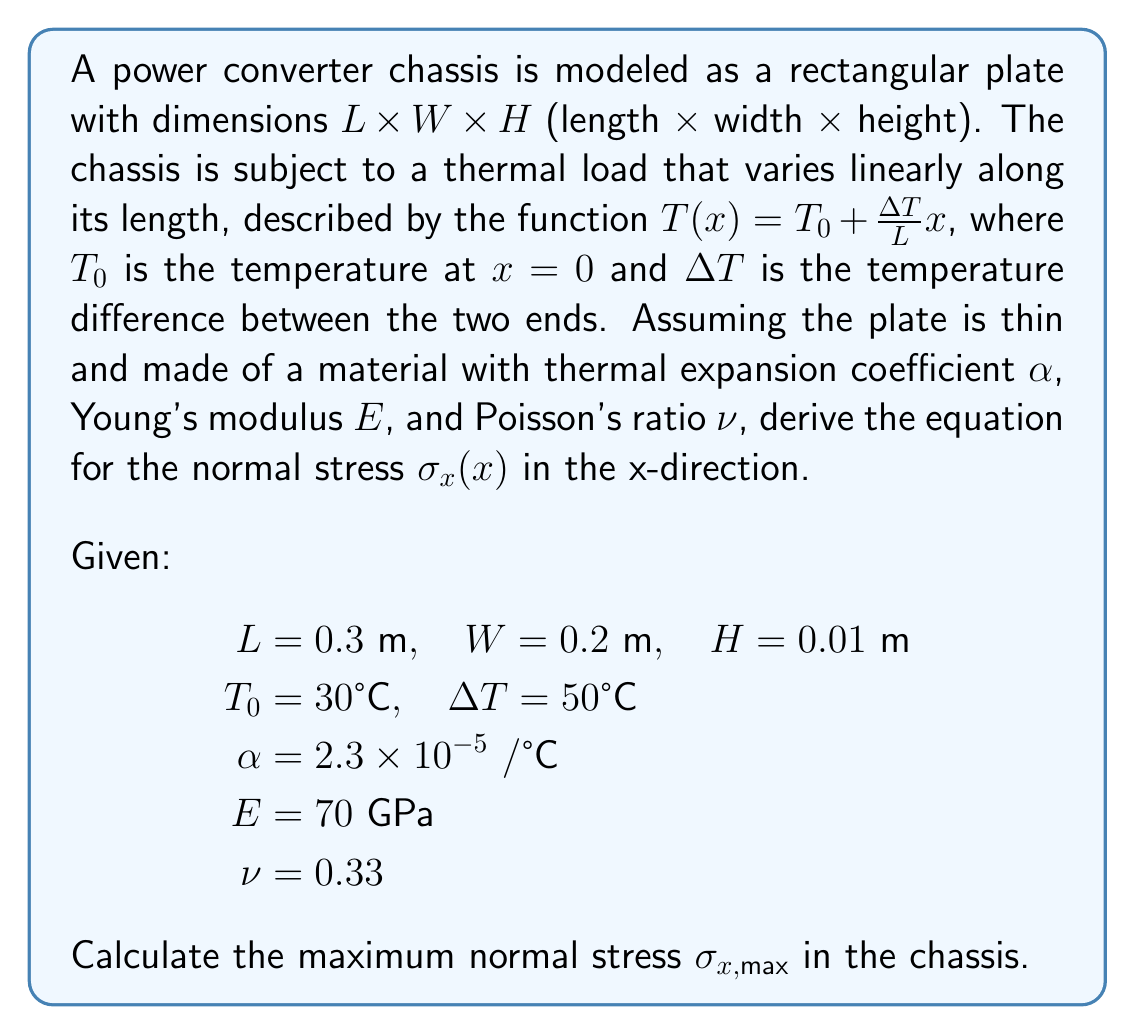Can you answer this question? To solve this problem, we'll follow these steps:

1) First, we need to understand that the thermal expansion of the plate is constrained, which leads to thermal stresses. The stress distribution will be linear along the x-direction due to the linear temperature distribution.

2) The general equation for thermal stress in a constrained plate is:

   $$\sigma_x(x) = -\alpha E [T(x) - T_{avg}]$$

   where $T_{avg}$ is the average temperature along the plate.

3) We need to calculate $T_{avg}$:

   $$T_{avg} = \frac{1}{L} \int_0^L T(x) dx = \frac{1}{L} \int_0^L (T_0 + \frac{\Delta T}{L}x) dx$$
   
   $$T_{avg} = T_0 + \frac{\Delta T}{2}$$

4) Now we can write the equation for $\sigma_x(x)$:

   $$\sigma_x(x) = -\alpha E [(T_0 + \frac{\Delta T}{L}x) - (T_0 + \frac{\Delta T}{2})]$$
   
   $$\sigma_x(x) = -\alpha E \Delta T (\frac{x}{L} - \frac{1}{2})$$

5) The maximum stress will occur at $x = L$ (or $x = 0$, as the absolute value will be the same):

   $$\sigma_{x,max} = |\alpha E \frac{\Delta T}{2}|$$

6) Now we can plug in the given values:

   $$\sigma_{x,max} = (2.3 \times 10^{-5})(70 \times 10^9)(\frac{50}{2})$$

7) Calculate the result:

   $$\sigma_{x,max} = 40.25 \times 10^6 \text{ Pa} = 40.25 \text{ MPa}$$
Answer: The maximum normal stress in the chassis is $\sigma_{x,max} = 40.25 \text{ MPa}$. 